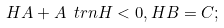Convert formula to latex. <formula><loc_0><loc_0><loc_500><loc_500>H A + A \ t r n H < 0 , H B = C ;</formula> 